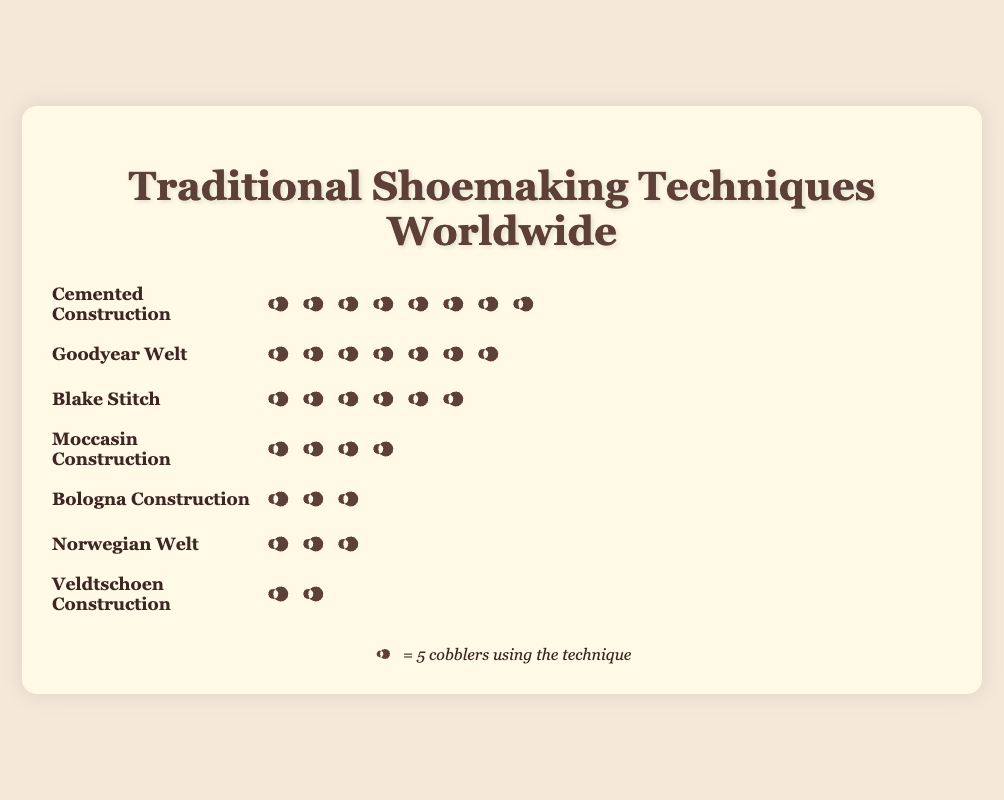How many cobblers use the Goodyear Welt technique? Count the number of icons in the Goodyear Welt row. There are 35 icons representing cobblers using this technique.
Answer: 35 Which technique is used by the most cobblers? Compare the counts of all techniques. Cemented Construction has the highest count with 40 cobblers.
Answer: Cemented Construction How many more cobblers use Cemented Construction compared to Norwegian Welt? Calculate the difference between the counts: 40 (Cemented) - 12 (Norwegian) = 28.
Answer: 28 Which technique is used by the fewest cobblers? Compare the counts of all techniques. Veldtschoen Construction has the fewest users with 8 cobblers.
Answer: Veldtschoen Construction How many techniques are represented in the figure? Count the number of named techniques in the figure. There are 7 techniques listed.
Answer: 7 What is the total number of cobblers represented in the figure? Sum the counts of all techniques: 35 (Goodyear Welt) + 28 (Blake Stitch) + 15 (Bologna Construction) + 12 (Norwegian Welt) + 20 (Moccasin Construction) + 40 (Cemented Construction) + 8 (Veldtschoen Construction) = 158.
Answer: 158 How many cobblers use techniques other than Cemented Construction? Subtract the count of Cemented Construction users from the total: 158 (total) - 40 (Cemented) = 118.
Answer: 118 Is the number of cobblers using Moccasin Construction higher or lower than those using Blake Stitch? Compare the counts: Moccasin Construction (20) is lower than Blake Stitch (28).
Answer: Lower What is the average number of cobblers per technique? Divide the total number of cobblers by the number of techniques: 158 (total) / 7 (techniques) = approximately 22.57.
Answer: Approximately 22.57 How many techniques have more than 20 cobblers using them? Identify and count the techniques with more than 20 cobblers: Goodyear Welt (35), Blake Stitch (28), and Cemented Construction (40). There are 3 such techniques.
Answer: 3 